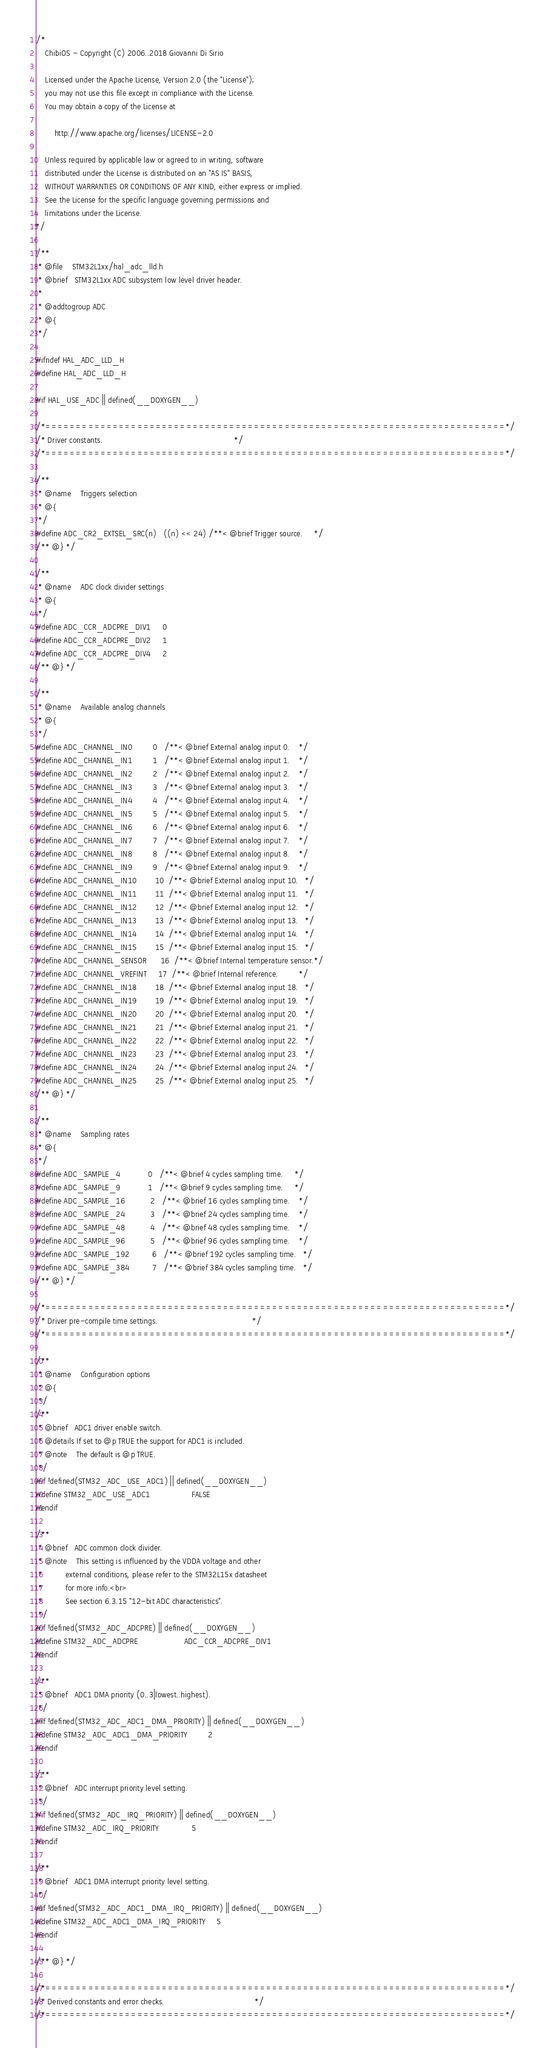<code> <loc_0><loc_0><loc_500><loc_500><_C_>/*
    ChibiOS - Copyright (C) 2006..2018 Giovanni Di Sirio

    Licensed under the Apache License, Version 2.0 (the "License");
    you may not use this file except in compliance with the License.
    You may obtain a copy of the License at

        http://www.apache.org/licenses/LICENSE-2.0

    Unless required by applicable law or agreed to in writing, software
    distributed under the License is distributed on an "AS IS" BASIS,
    WITHOUT WARRANTIES OR CONDITIONS OF ANY KIND, either express or implied.
    See the License for the specific language governing permissions and
    limitations under the License.
*/

/**
 * @file    STM32L1xx/hal_adc_lld.h
 * @brief   STM32L1xx ADC subsystem low level driver header.
 *
 * @addtogroup ADC
 * @{
 */

#ifndef HAL_ADC_LLD_H
#define HAL_ADC_LLD_H

#if HAL_USE_ADC || defined(__DOXYGEN__)

/*===========================================================================*/
/* Driver constants.                                                         */
/*===========================================================================*/

/**
 * @name    Triggers selection
 * @{
 */
#define ADC_CR2_EXTSEL_SRC(n)   ((n) << 24) /**< @brief Trigger source.     */
/** @} */

/**
 * @name    ADC clock divider settings
 * @{
 */
#define ADC_CCR_ADCPRE_DIV1     0
#define ADC_CCR_ADCPRE_DIV2     1
#define ADC_CCR_ADCPRE_DIV4     2
/** @} */

/**
 * @name    Available analog channels
 * @{
 */
#define ADC_CHANNEL_IN0         0   /**< @brief External analog input 0.    */
#define ADC_CHANNEL_IN1         1   /**< @brief External analog input 1.    */
#define ADC_CHANNEL_IN2         2   /**< @brief External analog input 2.    */
#define ADC_CHANNEL_IN3         3   /**< @brief External analog input 3.    */
#define ADC_CHANNEL_IN4         4   /**< @brief External analog input 4.    */
#define ADC_CHANNEL_IN5         5   /**< @brief External analog input 5.    */
#define ADC_CHANNEL_IN6         6   /**< @brief External analog input 6.    */
#define ADC_CHANNEL_IN7         7   /**< @brief External analog input 7.    */
#define ADC_CHANNEL_IN8         8   /**< @brief External analog input 8.    */
#define ADC_CHANNEL_IN9         9   /**< @brief External analog input 9.    */
#define ADC_CHANNEL_IN10        10  /**< @brief External analog input 10.   */
#define ADC_CHANNEL_IN11        11  /**< @brief External analog input 11.   */
#define ADC_CHANNEL_IN12        12  /**< @brief External analog input 12.   */
#define ADC_CHANNEL_IN13        13  /**< @brief External analog input 13.   */
#define ADC_CHANNEL_IN14        14  /**< @brief External analog input 14.   */
#define ADC_CHANNEL_IN15        15  /**< @brief External analog input 15.   */
#define ADC_CHANNEL_SENSOR      16  /**< @brief Internal temperature sensor.*/
#define ADC_CHANNEL_VREFINT     17  /**< @brief Internal reference.         */
#define ADC_CHANNEL_IN18        18  /**< @brief External analog input 18.   */
#define ADC_CHANNEL_IN19        19  /**< @brief External analog input 19.   */
#define ADC_CHANNEL_IN20        20  /**< @brief External analog input 20.   */
#define ADC_CHANNEL_IN21        21  /**< @brief External analog input 21.   */
#define ADC_CHANNEL_IN22        22  /**< @brief External analog input 22.   */
#define ADC_CHANNEL_IN23        23  /**< @brief External analog input 23.   */
#define ADC_CHANNEL_IN24        24  /**< @brief External analog input 24.   */
#define ADC_CHANNEL_IN25        25  /**< @brief External analog input 25.   */
/** @} */

/**
 * @name    Sampling rates
 * @{
 */
#define ADC_SAMPLE_4            0   /**< @brief 4 cycles sampling time.     */
#define ADC_SAMPLE_9            1   /**< @brief 9 cycles sampling time.     */
#define ADC_SAMPLE_16           2   /**< @brief 16 cycles sampling time.    */
#define ADC_SAMPLE_24           3   /**< @brief 24 cycles sampling time.    */
#define ADC_SAMPLE_48           4   /**< @brief 48 cycles sampling time.    */
#define ADC_SAMPLE_96           5   /**< @brief 96 cycles sampling time.    */
#define ADC_SAMPLE_192          6   /**< @brief 192 cycles sampling time.   */
#define ADC_SAMPLE_384          7   /**< @brief 384 cycles sampling time.   */
/** @} */

/*===========================================================================*/
/* Driver pre-compile time settings.                                         */
/*===========================================================================*/

/**
 * @name    Configuration options
 * @{
 */
/**
 * @brief   ADC1 driver enable switch.
 * @details If set to @p TRUE the support for ADC1 is included.
 * @note    The default is @p TRUE.
 */
#if !defined(STM32_ADC_USE_ADC1) || defined(__DOXYGEN__)
#define STM32_ADC_USE_ADC1                  FALSE
#endif

/**
 * @brief   ADC common clock divider.
 * @note    This setting is influenced by the VDDA voltage and other
 *          external conditions, please refer to the STM32L15x datasheet
 *          for more info.<br>
 *          See section 6.3.15 "12-bit ADC characteristics".
 */
#if !defined(STM32_ADC_ADCPRE) || defined(__DOXYGEN__)
#define STM32_ADC_ADCPRE                    ADC_CCR_ADCPRE_DIV1
#endif

/**
 * @brief   ADC1 DMA priority (0..3|lowest..highest).
 */
#if !defined(STM32_ADC_ADC1_DMA_PRIORITY) || defined(__DOXYGEN__)
#define STM32_ADC_ADC1_DMA_PRIORITY         2
#endif

/**
 * @brief   ADC interrupt priority level setting.
 */
#if !defined(STM32_ADC_IRQ_PRIORITY) || defined(__DOXYGEN__)
#define STM32_ADC_IRQ_PRIORITY              5
#endif

/**
 * @brief   ADC1 DMA interrupt priority level setting.
 */
#if !defined(STM32_ADC_ADC1_DMA_IRQ_PRIORITY) || defined(__DOXYGEN__)
#define STM32_ADC_ADC1_DMA_IRQ_PRIORITY     5
#endif

/** @} */

/*===========================================================================*/
/* Derived constants and error checks.                                       */
/*===========================================================================*/
</code> 